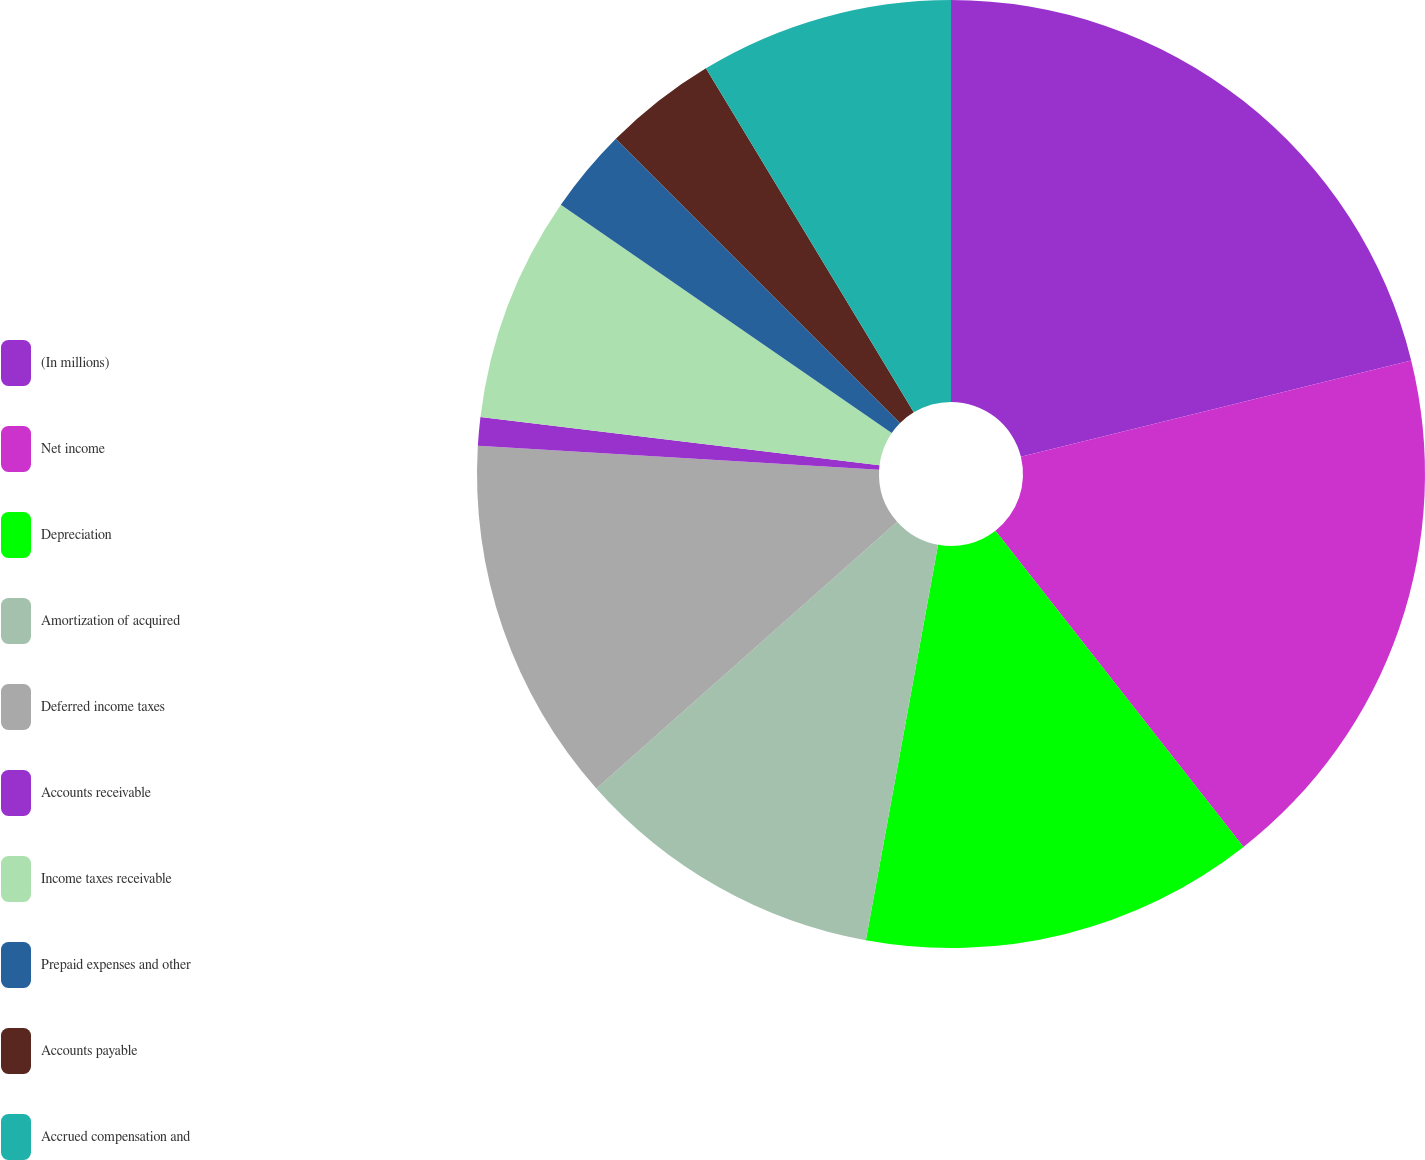Convert chart to OTSL. <chart><loc_0><loc_0><loc_500><loc_500><pie_chart><fcel>(In millions)<fcel>Net income<fcel>Depreciation<fcel>Amortization of acquired<fcel>Deferred income taxes<fcel>Accounts receivable<fcel>Income taxes receivable<fcel>Prepaid expenses and other<fcel>Accounts payable<fcel>Accrued compensation and<nl><fcel>21.15%<fcel>18.27%<fcel>13.46%<fcel>10.58%<fcel>12.5%<fcel>0.97%<fcel>7.69%<fcel>2.89%<fcel>3.85%<fcel>8.65%<nl></chart> 